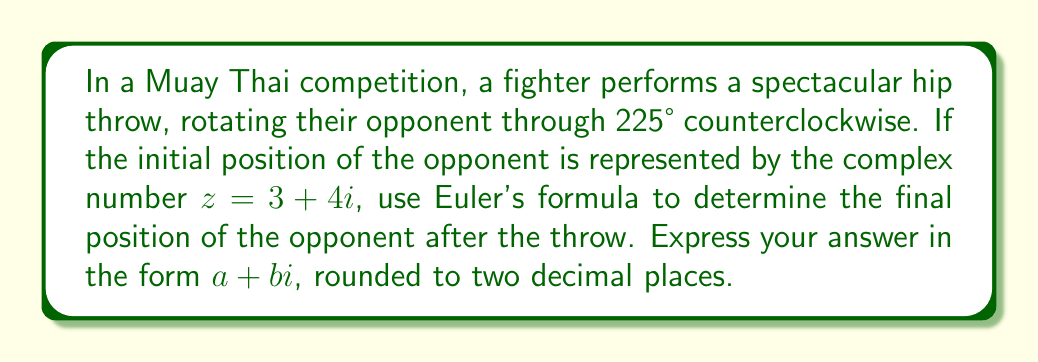Can you solve this math problem? Let's approach this step-by-step:

1) Euler's formula for rotation is given by:
   $$z' = z \cdot e^{i\theta}$$
   where $z'$ is the rotated position, $z$ is the initial position, and $\theta$ is the angle of rotation in radians.

2) We need to convert 225° to radians:
   $$\theta = 225° \cdot \frac{\pi}{180°} = \frac{5\pi}{4} \text{ radians}$$

3) Now, let's substitute into Euler's formula:
   $$z' = (3 + 4i) \cdot e^{i\frac{5\pi}{4}}$$

4) Expand $e^{i\frac{5\pi}{4}}$ using Euler's formula:
   $$e^{i\frac{5\pi}{4}} = \cos(\frac{5\pi}{4}) + i\sin(\frac{5\pi}{4})$$

5) Calculate these values:
   $$\cos(\frac{5\pi}{4}) = -\frac{\sqrt{2}}{2}, \quad \sin(\frac{5\pi}{4}) = -\frac{\sqrt{2}}{2}$$

6) Substitute back:
   $$z' = (3 + 4i) \cdot (-\frac{\sqrt{2}}{2} - i\frac{\sqrt{2}}{2})$$

7) Multiply the complex numbers:
   $$z' = (-\frac{3\sqrt{2}}{2} + \frac{4\sqrt{2}}{2}) + (-\frac{4\sqrt{2}}{2} - \frac{3\sqrt{2}}{2})i$$

8) Simplify:
   $$z' = \frac{\sqrt{2}}{2} - \frac{7\sqrt{2}}{2}i$$

9) Convert to decimal form and round to two decimal places:
   $$z' \approx 0.71 - 4.95i$$
Answer: $0.71 - 4.95i$ 